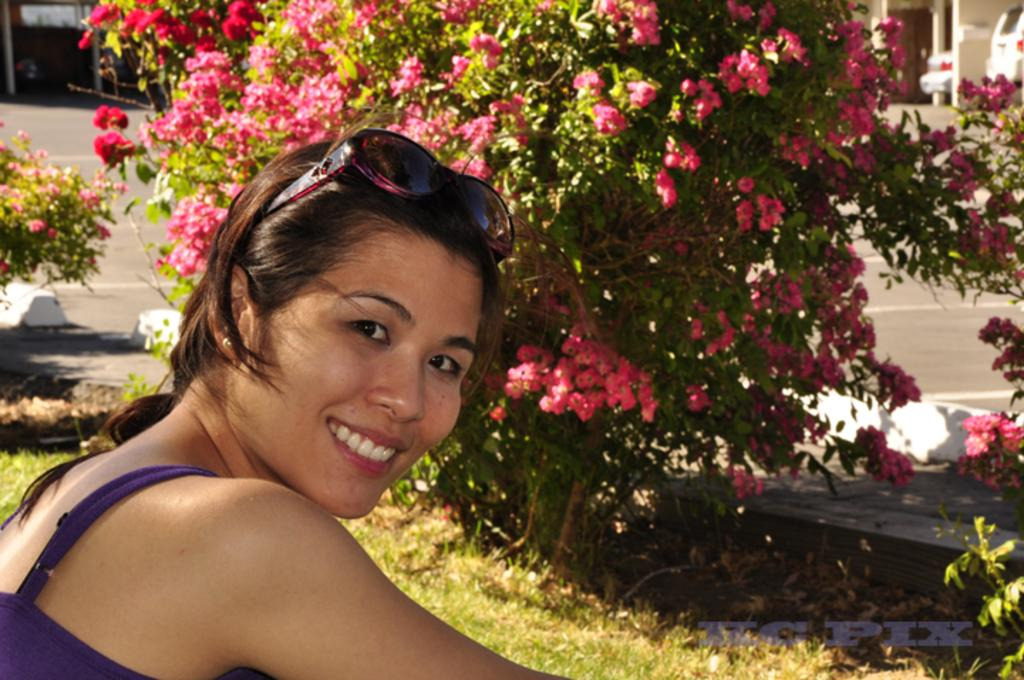Who is present in the image? There is a woman in the image. What is the woman's facial expression? The woman is smiling. What is the woman wearing that covers her eyes? The woman is wearing shades. What can be seen in the background of the image? There are flower plants, grass, vehicles, and other objects on the ground visible in the background of the image. What type of cough medicine is the woman holding in the image? There is no cough medicine present in the image; the woman is wearing shades and smiling. How many toes can be seen on the woman's feet in the image? The image does not show the woman's feet, so it is not possible to determine the number of toes. 